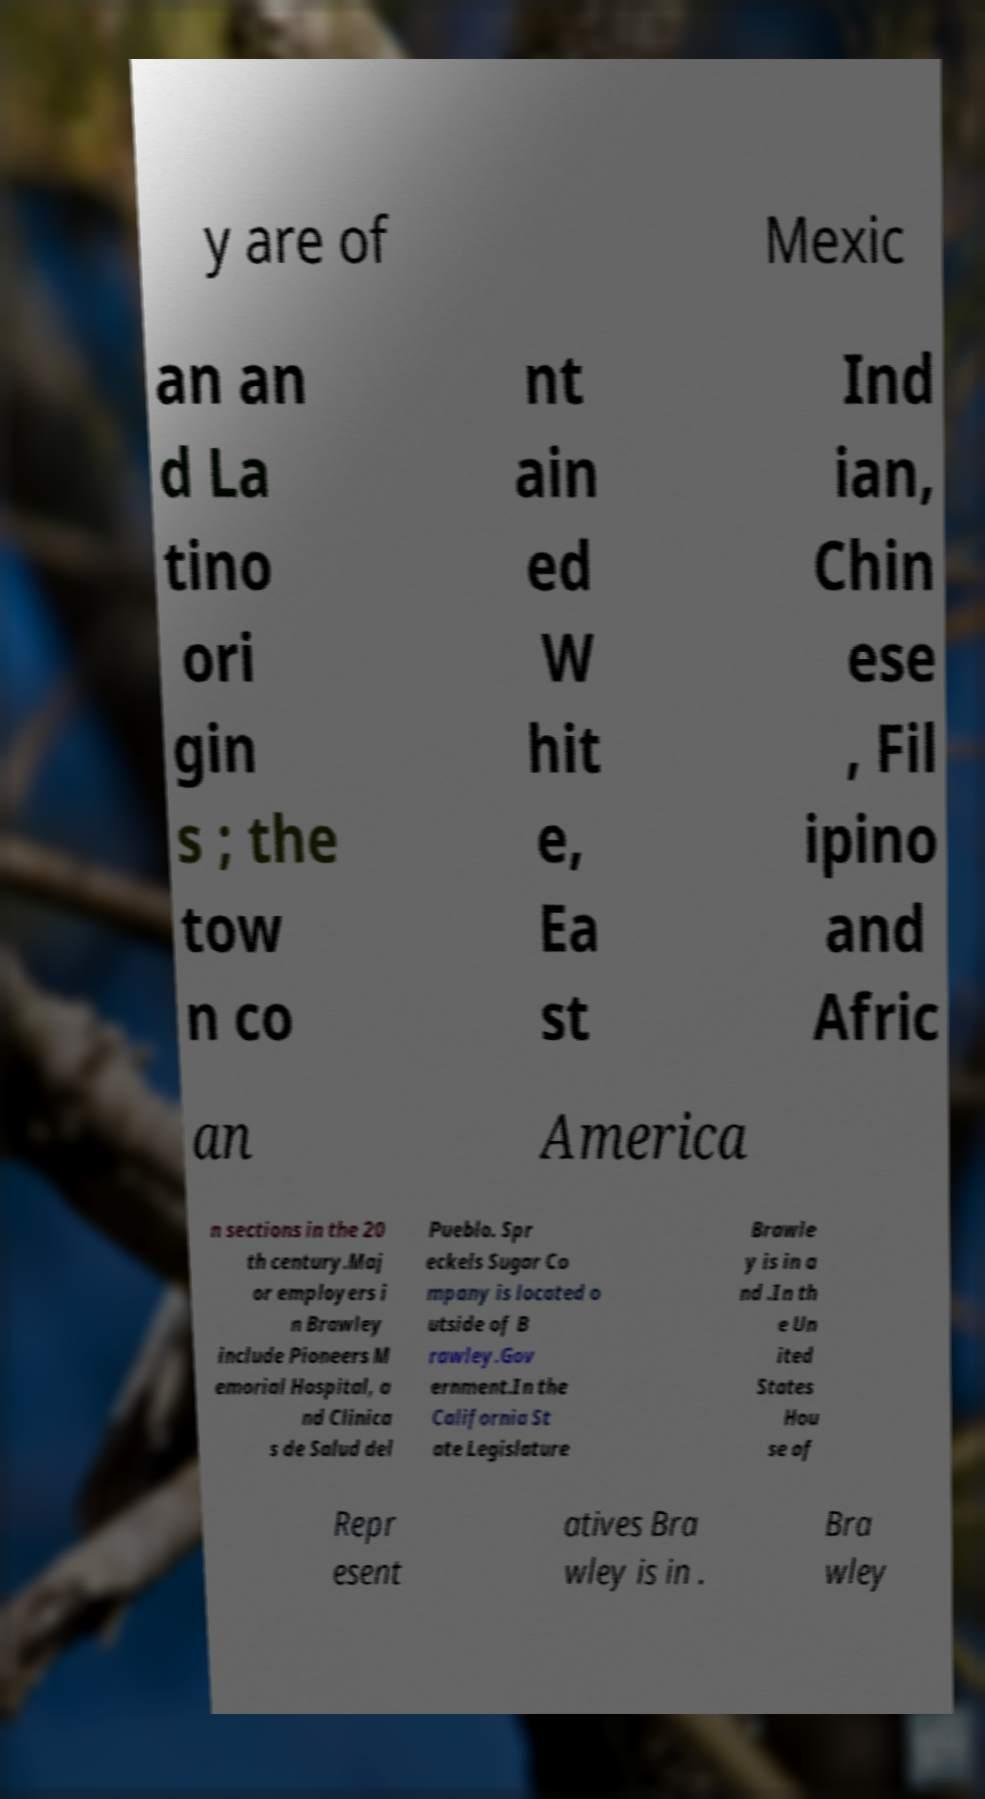There's text embedded in this image that I need extracted. Can you transcribe it verbatim? y are of Mexic an an d La tino ori gin s ; the tow n co nt ain ed W hit e, Ea st Ind ian, Chin ese , Fil ipino and Afric an America n sections in the 20 th century.Maj or employers i n Brawley include Pioneers M emorial Hospital, a nd Clinica s de Salud del Pueblo. Spr eckels Sugar Co mpany is located o utside of B rawley.Gov ernment.In the California St ate Legislature Brawle y is in a nd .In th e Un ited States Hou se of Repr esent atives Bra wley is in . Bra wley 